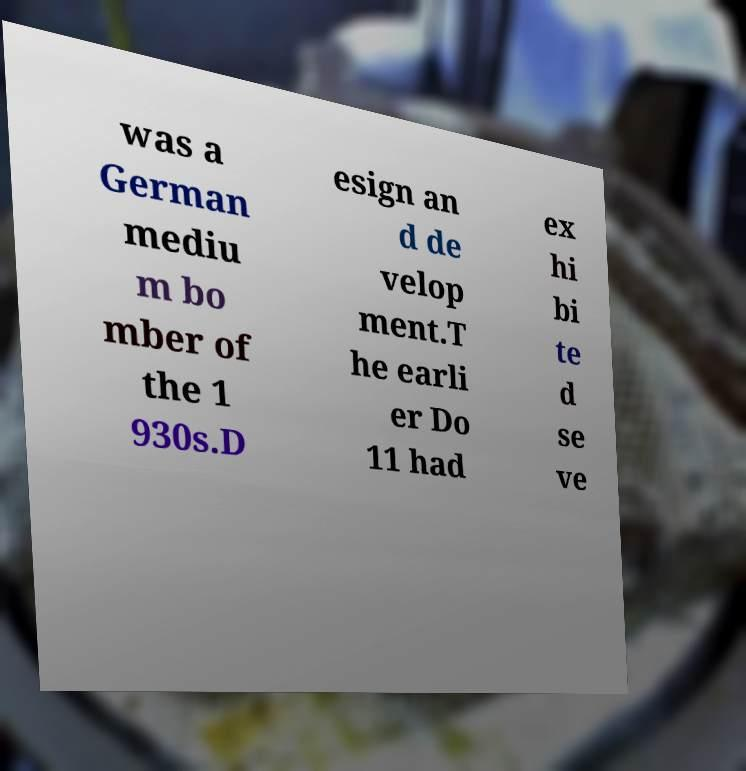There's text embedded in this image that I need extracted. Can you transcribe it verbatim? was a German mediu m bo mber of the 1 930s.D esign an d de velop ment.T he earli er Do 11 had ex hi bi te d se ve 